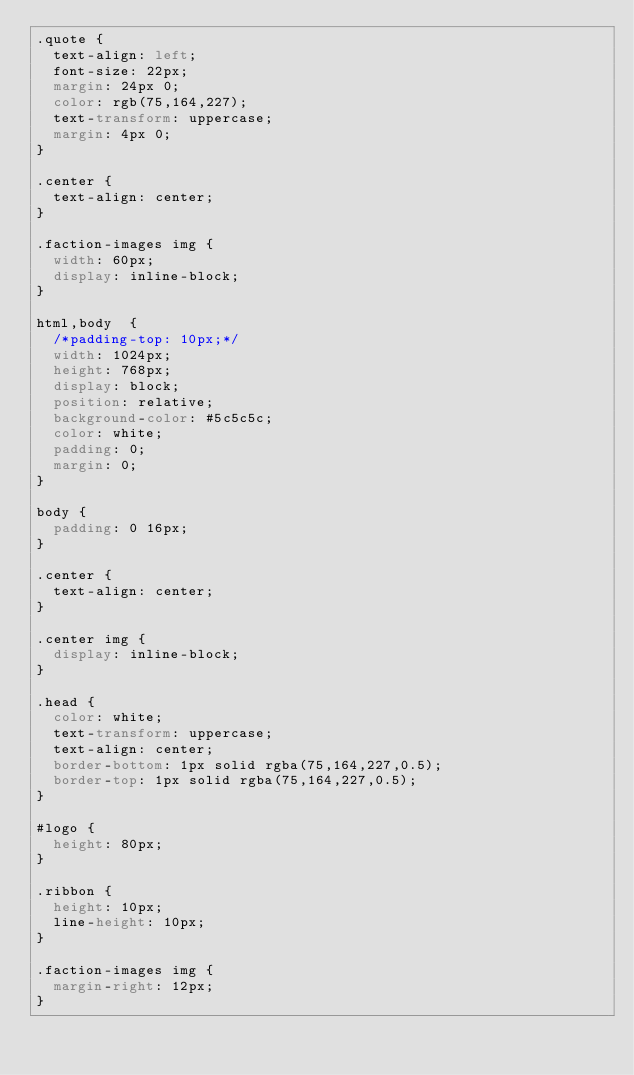<code> <loc_0><loc_0><loc_500><loc_500><_CSS_>.quote {
  text-align: left;
  font-size: 22px;
  margin: 24px 0;
  color: rgb(75,164,227);
  text-transform: uppercase;
  margin: 4px 0;
}

.center {
  text-align: center;
}

.faction-images img {
  width: 60px;  
  display: inline-block;
}

html,body  {
  /*padding-top: 10px;*/
  width: 1024px;
  height: 768px;
  display: block;
  position: relative;
  background-color: #5c5c5c;
  color: white;
  padding: 0;
  margin: 0;
}

body {
  padding: 0 16px;
}

.center {
  text-align: center;
}

.center img {
  display: inline-block;
}

.head {
  color: white;
  text-transform: uppercase;
  text-align: center;
  border-bottom: 1px solid rgba(75,164,227,0.5);
  border-top: 1px solid rgba(75,164,227,0.5);
}

#logo {
  height: 80px;
}

.ribbon {
  height: 10px;
  line-height: 10px;
}

.faction-images img {
  margin-right: 12px;
}</code> 